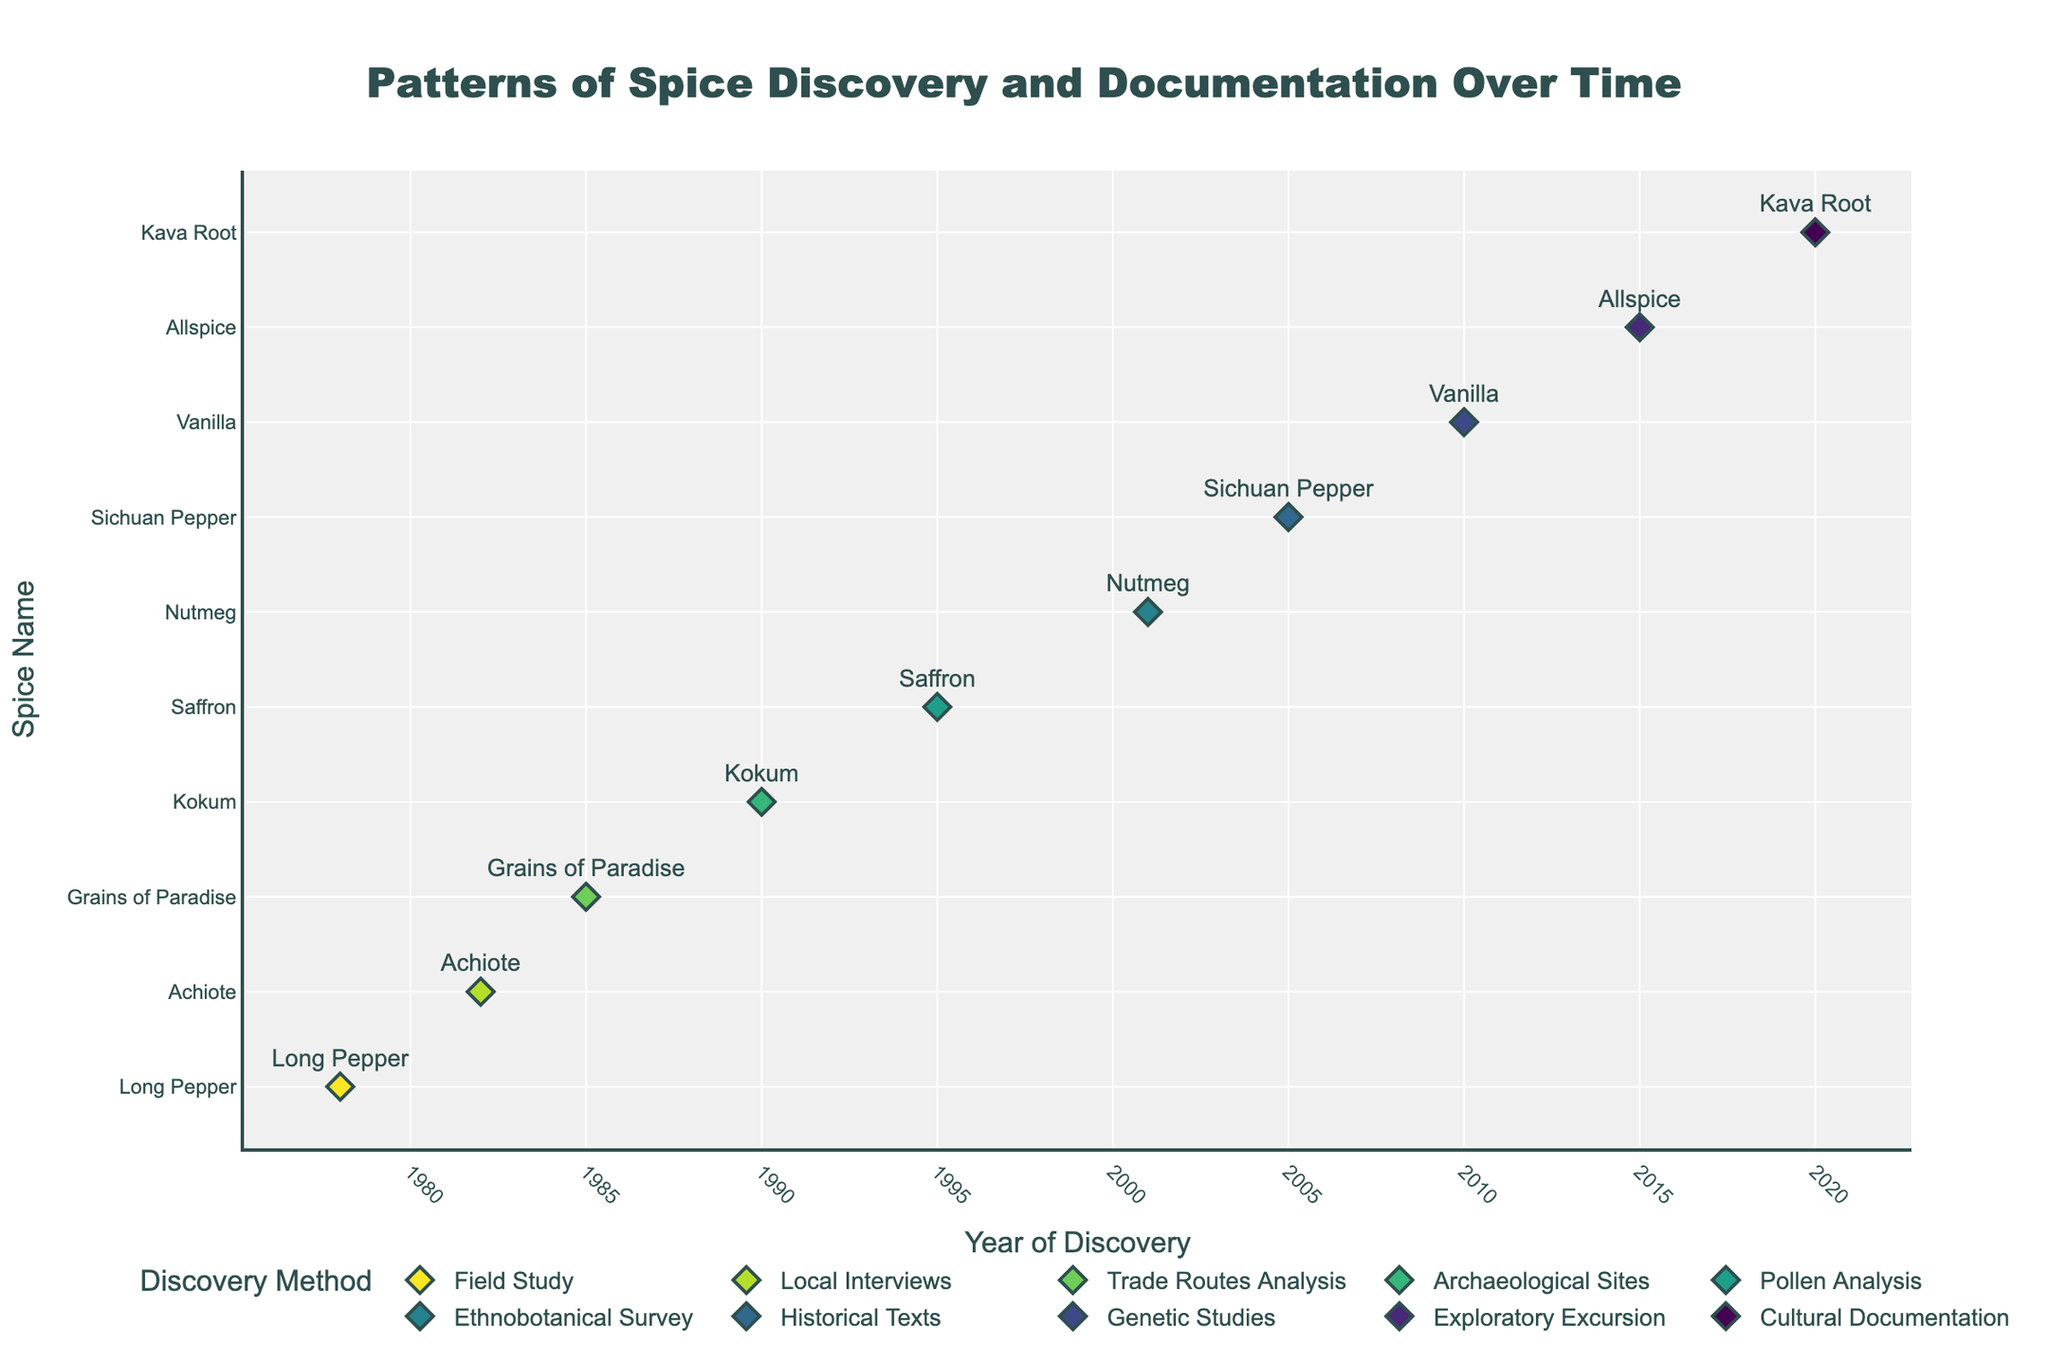What is the title of the plot? The title is usually located at the top of the figure and explains the main topic or focus of the plot. In this case, the title is: "Patterns of Spice Discovery and Documentation Over Time".
Answer: Patterns of Spice Discovery and Documentation Over Time Which spice was discovered in 2001? Locate the year 2001 on the x-axis and identify the spice name corresponding to this year. The spice discovered in 2001 is Nutmeg.
Answer: Nutmeg How many discovery methods are represented in the plot? Each discovery method is represented by a different colored marker. By going through the legend, we count the unique discovery methods.
Answer: 8 Which spice was documented by Dr. Hannah Shaw? Identify the spice related to Dr. Hannah Shaw by checking the hover information for each data point or reviewing the text associated with the plotted markers. Dr. Hannah Shaw documented Saffron.
Answer: Saffron Which regions have more than one spice documented? Check each region mentioned in the custom data for each spice to identify any regions that appear more than once. Only Southeast Asia appears twice with Long Pepper and Saffron.
Answer: Southeast Asia What year saw the discovery of Vanilla, and which method was used? Identify the spice name Vanilla, then trace its corresponding year on the x-axis and look for the discovery method. Vanilla was discovered in 2010 using Genetic Studies.
Answer: 2010, Genetic Studies Compare the number of spices discovered through 'Field Study' and 'Trade Routes Analysis'. Count the data points for each method by referring to the legend and markers color. 'Field Study' discovered 1 spice, and 'Trade Routes Analysis' discovered 1 spice, so both methods discovered an equal number of spices.
Answer: equal Identify the first and the last spices documented in the timeline. By examining the x-axis from the earliest to the latest year, the first spice documented is Long Pepper (1978) and the last spice is Kava Root (2020).
Answer: Long Pepper (1978), Kava Root (2020) How many years after the discovery of Achiote was Sichuan Pepper discovered? Determine the years of discovery for both spices and calculate the time difference. Achiote was discovered in 1982 and Sichuan Pepper in 2005. The difference is 2005 - 1982 = 23 years.
Answer: 23 years 